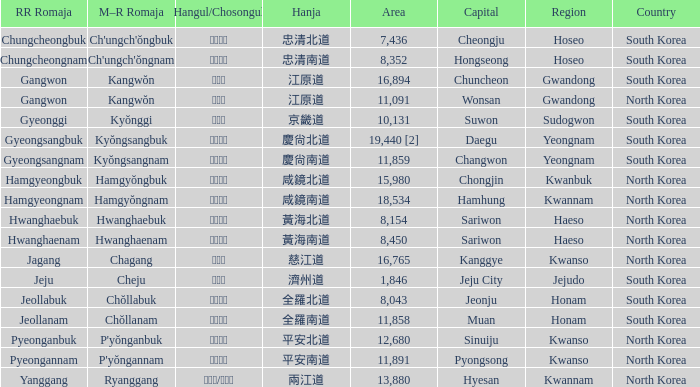What is the rr romaja of the province with the hangul notation 강원도 and its capital city being wonsan? Gangwon. 